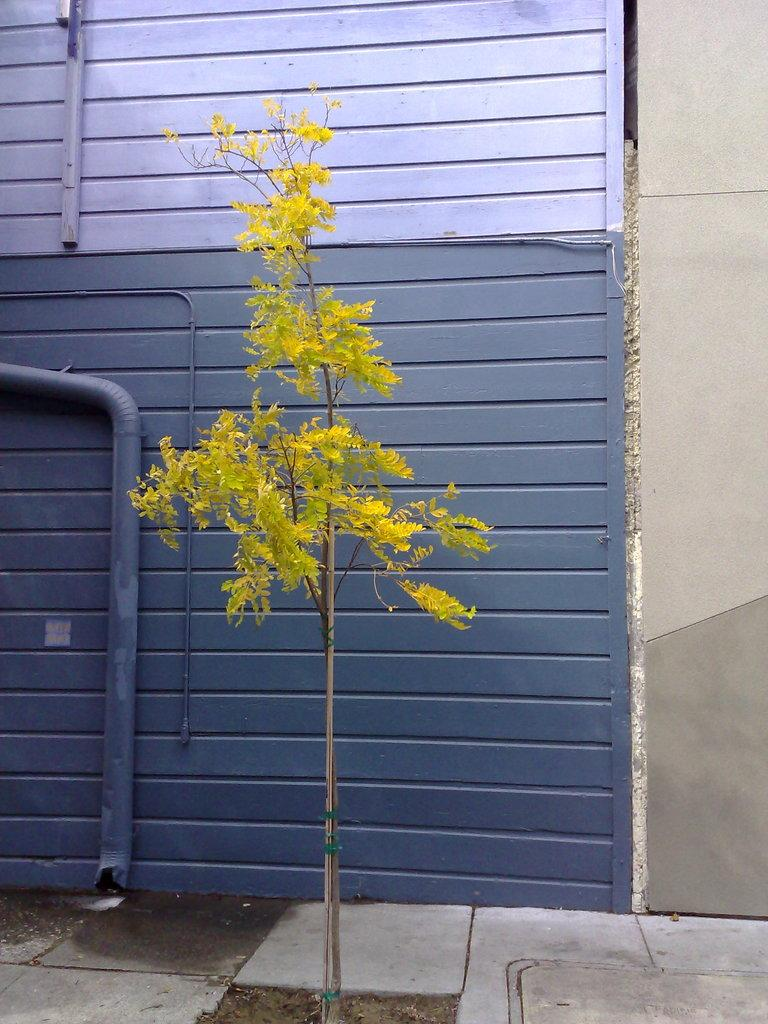What type of living organism can be seen in the image? There is a plant in the image. What is the color of the gate in the image? The gate in the image is grey. What is the color of the wall in the image? The wall in the image is light brown. What type of caption is present on the plant in the image? There is no caption present on the plant in the image. Where is the faucet located in the image? There is no faucet present in the image. 